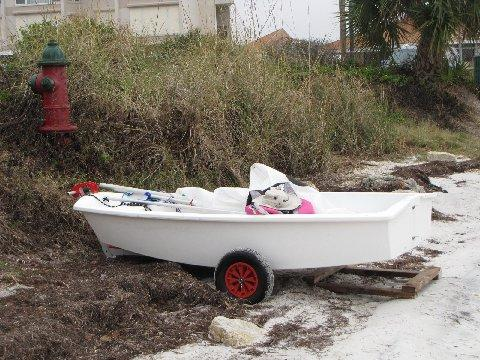Identify the color and characteristics of the fire hydrant in the image. The fire hydrant is red and green, with green on top and red on the bottom. Explain the state of the ground near the white small boat. The ground near the white small boat is covered in sand, brown dirt, and a wooden frame or plank. What is the main object found in the small white boat? The main object in the small white boat is a pink and white item, possibly a tarp or plastic material. Analyze the environment and provide a possible sentiment attached to the image. The image seems to portray a serene and natural environment, featuring a beach setting with a boat on the shore, sand, rocks, and a hill with growing plants, suggesting a calm and peaceful sentiment. Please list the key items on the beach in order of their proximity to the shoreline. Starting from the shoreline, there is sand, seaweed, a white rock, a fire hydrant, and a wooden pallet. Describe the location and details of the house in the image. The white house is in the background, with white garages, a tan-colored roof and situated on a hill with multiple growing plants. What type of tree is in the image and what is its relation to the other objects? There is a palm tree on the hill, which is close to the cement building and the white house with white garages. What is underneath the boat, and what is the color of the boat's wheels? Underneath the boat, there is a brown wooden plank, and the boat's wheels are red. Provide a count of unique objects in the image. There are 17 unique objects in the image, including a fire hydrant, tire, chains, plank, boulder, dirt, item in boat, sand, hill, house, boat, rock, hat, poles, seaweed, palm tree, and wooden frame. Assess the quality of the image based on the clarity and visibility of the objects. The image quality can be considered good since the objects are distinguishable and their positions, sizes, and colors are clearly described. Locate the flock of seagulls flying above the beach near the palm tree. Observe their elegant formation. The image information does not mention any birds, particularly seagulls. By mentioning a group (flock) and a specific location (above the beach near the palm tree), the instruction becomes more deceptive. Look for the person wearing a red shirt and blue shorts, standing near the small white boat on the shore. What is he doing? There is no mention of a person in the provided image information. By specifying the attire (red shirt and blue shorts) and location (near the small white boat), the instruction becomes more misleading. Can you spot the tall coconut tree beside the white building on the hill? Look for its distinctive arched trunk and large leaves. There is no mention of a coconut tree in the image, only a palm tree is mentioned which might not be the same. By adding specific details like an arched trunk and large leaves, the instruction becomes more deceptive. Identify the orange traffic cone placed next to the red and green fire hydrant in the grass. Take note of the visible wear and tear. There is no mention of an orange traffic cone in the available information about the image. Adding an observable characteristic like "visible wear and tear" increases the instruction's misleading nature. Can you find the purple bicycle leaning against the white house? It has a small basket attached to the handlebars. There is no mention of a bicycle in the image, let alone a purple one with a basket. Using a specific color and additional detail like the basket makes the instruction more misleading. Where is the yellow umbrella providing shade to a sunbather on the sandy shoreline? Notice the bright colors and patterns on the umbrella. No yellow umbrella or sunbather is mentioned in the list of objects in the image. By describing additional features like bright colors and patterns on the non-existent umbrella, the instruction becomes more false and misleading. 